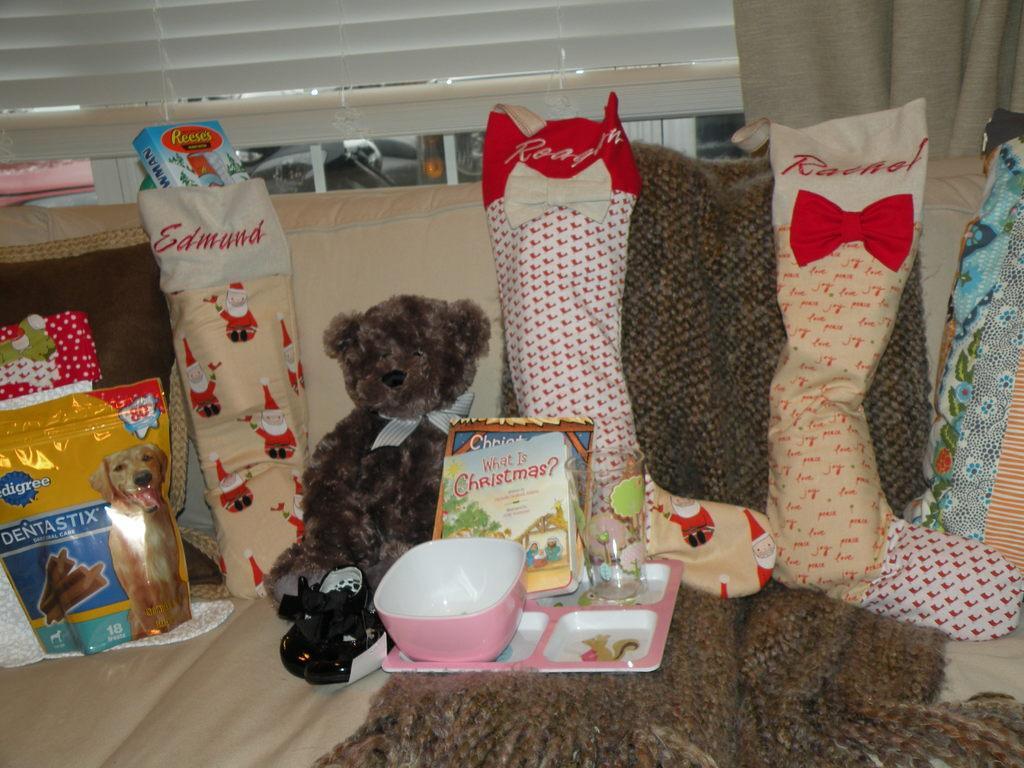How would you summarize this image in a sentence or two? In this picture I can see blinds and curtains in the back and I can see few christmas socks and few items in them and a dog food packet on the left side. I can see a soft toy, book, plate, bowl and a glass on the sofa and I can see a cloth. 